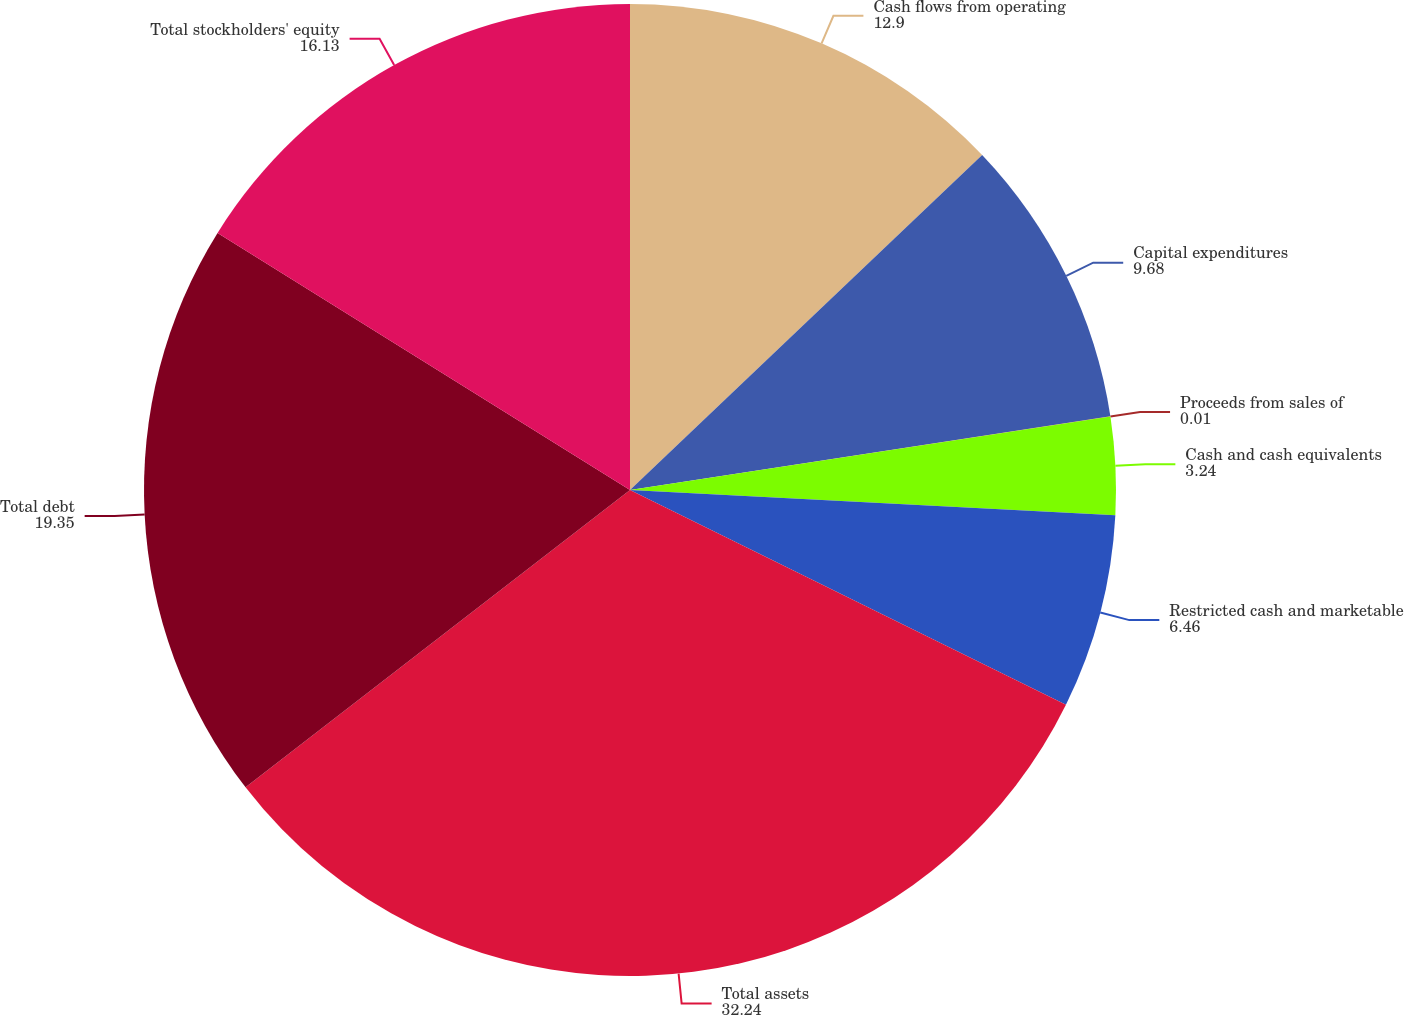<chart> <loc_0><loc_0><loc_500><loc_500><pie_chart><fcel>Cash flows from operating<fcel>Capital expenditures<fcel>Proceeds from sales of<fcel>Cash and cash equivalents<fcel>Restricted cash and marketable<fcel>Total assets<fcel>Total debt<fcel>Total stockholders' equity<nl><fcel>12.9%<fcel>9.68%<fcel>0.01%<fcel>3.24%<fcel>6.46%<fcel>32.24%<fcel>19.35%<fcel>16.13%<nl></chart> 